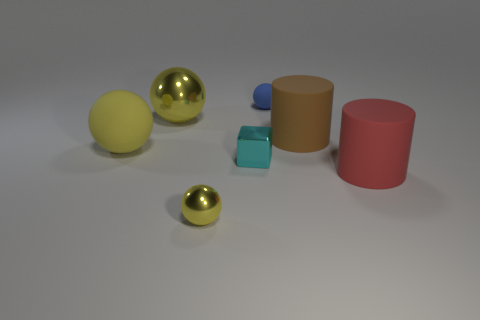Is there anything else that has the same shape as the cyan object?
Make the answer very short. No. What material is the tiny thing that is the same color as the big metallic thing?
Keep it short and to the point. Metal. The yellow sphere that is both on the right side of the yellow matte object and in front of the big metal ball is made of what material?
Your answer should be very brief. Metal. Do the red cylinder and the small cube have the same material?
Make the answer very short. No. There is a yellow sphere that is both behind the small cyan shiny object and in front of the brown matte thing; what is its size?
Keep it short and to the point. Large. What is the shape of the brown matte object?
Ensure brevity in your answer.  Cylinder. What number of things are big matte spheres or big yellow spheres in front of the big yellow metallic ball?
Your answer should be very brief. 1. There is a metal sphere behind the small metal sphere; does it have the same color as the big matte ball?
Your answer should be compact. Yes. What color is the object that is both in front of the brown cylinder and right of the tiny matte ball?
Ensure brevity in your answer.  Red. What is the big yellow object to the left of the big yellow metallic object made of?
Keep it short and to the point. Rubber. 